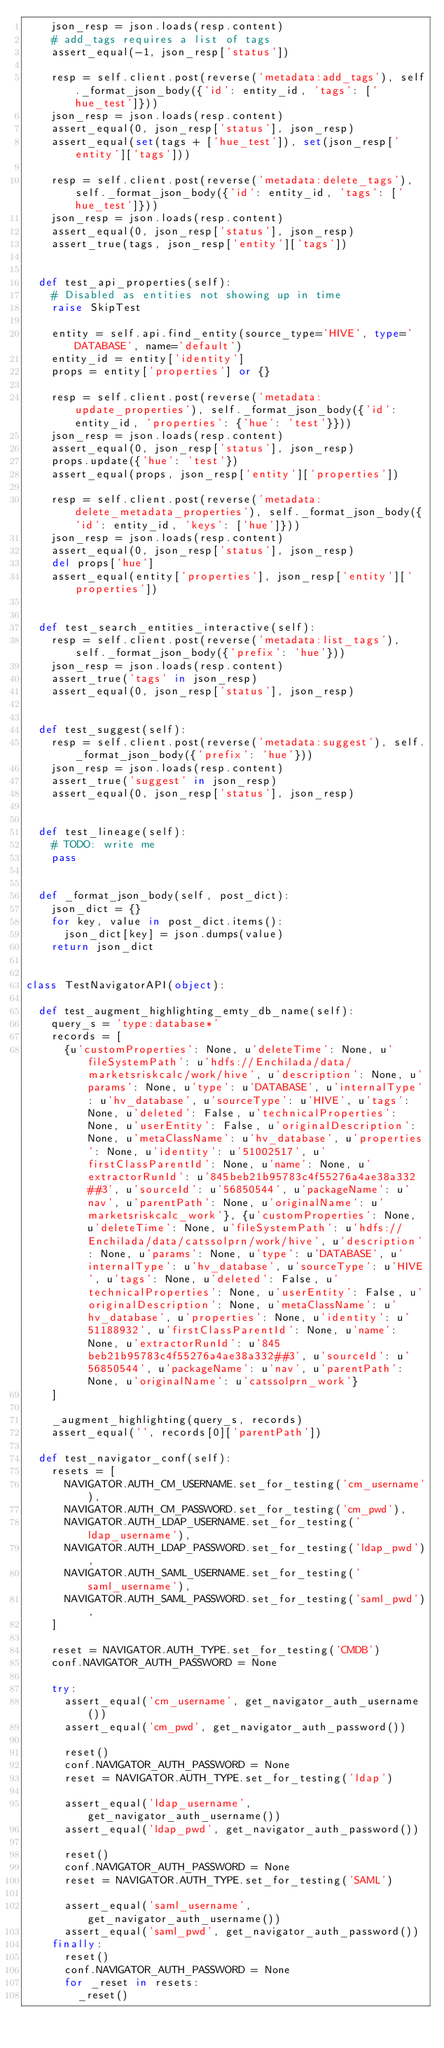Convert code to text. <code><loc_0><loc_0><loc_500><loc_500><_Python_>    json_resp = json.loads(resp.content)
    # add_tags requires a list of tags
    assert_equal(-1, json_resp['status'])

    resp = self.client.post(reverse('metadata:add_tags'), self._format_json_body({'id': entity_id, 'tags': ['hue_test']}))
    json_resp = json.loads(resp.content)
    assert_equal(0, json_resp['status'], json_resp)
    assert_equal(set(tags + ['hue_test']), set(json_resp['entity']['tags']))

    resp = self.client.post(reverse('metadata:delete_tags'), self._format_json_body({'id': entity_id, 'tags': ['hue_test']}))
    json_resp = json.loads(resp.content)
    assert_equal(0, json_resp['status'], json_resp)
    assert_true(tags, json_resp['entity']['tags'])


  def test_api_properties(self):
    # Disabled as entities not showing up in time
    raise SkipTest

    entity = self.api.find_entity(source_type='HIVE', type='DATABASE', name='default')
    entity_id = entity['identity']
    props = entity['properties'] or {}

    resp = self.client.post(reverse('metadata:update_properties'), self._format_json_body({'id': entity_id, 'properties': {'hue': 'test'}}))
    json_resp = json.loads(resp.content)
    assert_equal(0, json_resp['status'], json_resp)
    props.update({'hue': 'test'})
    assert_equal(props, json_resp['entity']['properties'])

    resp = self.client.post(reverse('metadata:delete_metadata_properties'), self._format_json_body({'id': entity_id, 'keys': ['hue']}))
    json_resp = json.loads(resp.content)
    assert_equal(0, json_resp['status'], json_resp)
    del props['hue']
    assert_equal(entity['properties'], json_resp['entity']['properties'])


  def test_search_entities_interactive(self):
    resp = self.client.post(reverse('metadata:list_tags'), self._format_json_body({'prefix': 'hue'}))
    json_resp = json.loads(resp.content)
    assert_true('tags' in json_resp)
    assert_equal(0, json_resp['status'], json_resp)


  def test_suggest(self):
    resp = self.client.post(reverse('metadata:suggest'), self._format_json_body({'prefix': 'hue'}))
    json_resp = json.loads(resp.content)
    assert_true('suggest' in json_resp)
    assert_equal(0, json_resp['status'], json_resp)


  def test_lineage(self):
    # TODO: write me
    pass


  def _format_json_body(self, post_dict):
    json_dict = {}
    for key, value in post_dict.items():
      json_dict[key] = json.dumps(value)
    return json_dict


class TestNavigatorAPI(object):

  def test_augment_highlighting_emty_db_name(self):
    query_s = 'type:database*'
    records = [
      {u'customProperties': None, u'deleteTime': None, u'fileSystemPath': u'hdfs://Enchilada/data/marketsriskcalc/work/hive', u'description': None, u'params': None, u'type': u'DATABASE', u'internalType': u'hv_database', u'sourceType': u'HIVE', u'tags': None, u'deleted': False, u'technicalProperties': None, u'userEntity': False, u'originalDescription': None, u'metaClassName': u'hv_database', u'properties': None, u'identity': u'51002517', u'firstClassParentId': None, u'name': None, u'extractorRunId': u'845beb21b95783c4f55276a4ae38a332##3', u'sourceId': u'56850544', u'packageName': u'nav', u'parentPath': None, u'originalName': u'marketsriskcalc_work'}, {u'customProperties': None, u'deleteTime': None, u'fileSystemPath': u'hdfs://Enchilada/data/catssolprn/work/hive', u'description': None, u'params': None, u'type': u'DATABASE', u'internalType': u'hv_database', u'sourceType': u'HIVE', u'tags': None, u'deleted': False, u'technicalProperties': None, u'userEntity': False, u'originalDescription': None, u'metaClassName': u'hv_database', u'properties': None, u'identity': u'51188932', u'firstClassParentId': None, u'name': None, u'extractorRunId': u'845beb21b95783c4f55276a4ae38a332##3', u'sourceId': u'56850544', u'packageName': u'nav', u'parentPath': None, u'originalName': u'catssolprn_work'}
    ]

    _augment_highlighting(query_s, records)
    assert_equal('', records[0]['parentPath'])

  def test_navigator_conf(self):
    resets = [
      NAVIGATOR.AUTH_CM_USERNAME.set_for_testing('cm_username'),
      NAVIGATOR.AUTH_CM_PASSWORD.set_for_testing('cm_pwd'),
      NAVIGATOR.AUTH_LDAP_USERNAME.set_for_testing('ldap_username'),
      NAVIGATOR.AUTH_LDAP_PASSWORD.set_for_testing('ldap_pwd'),
      NAVIGATOR.AUTH_SAML_USERNAME.set_for_testing('saml_username'),
      NAVIGATOR.AUTH_SAML_PASSWORD.set_for_testing('saml_pwd'),
    ]

    reset = NAVIGATOR.AUTH_TYPE.set_for_testing('CMDB')
    conf.NAVIGATOR_AUTH_PASSWORD = None

    try:
      assert_equal('cm_username', get_navigator_auth_username())
      assert_equal('cm_pwd', get_navigator_auth_password())

      reset()
      conf.NAVIGATOR_AUTH_PASSWORD = None
      reset = NAVIGATOR.AUTH_TYPE.set_for_testing('ldap')

      assert_equal('ldap_username', get_navigator_auth_username())
      assert_equal('ldap_pwd', get_navigator_auth_password())

      reset()
      conf.NAVIGATOR_AUTH_PASSWORD = None
      reset = NAVIGATOR.AUTH_TYPE.set_for_testing('SAML')

      assert_equal('saml_username', get_navigator_auth_username())
      assert_equal('saml_pwd', get_navigator_auth_password())
    finally:
      reset()
      conf.NAVIGATOR_AUTH_PASSWORD = None
      for _reset in resets:
        _reset()
</code> 